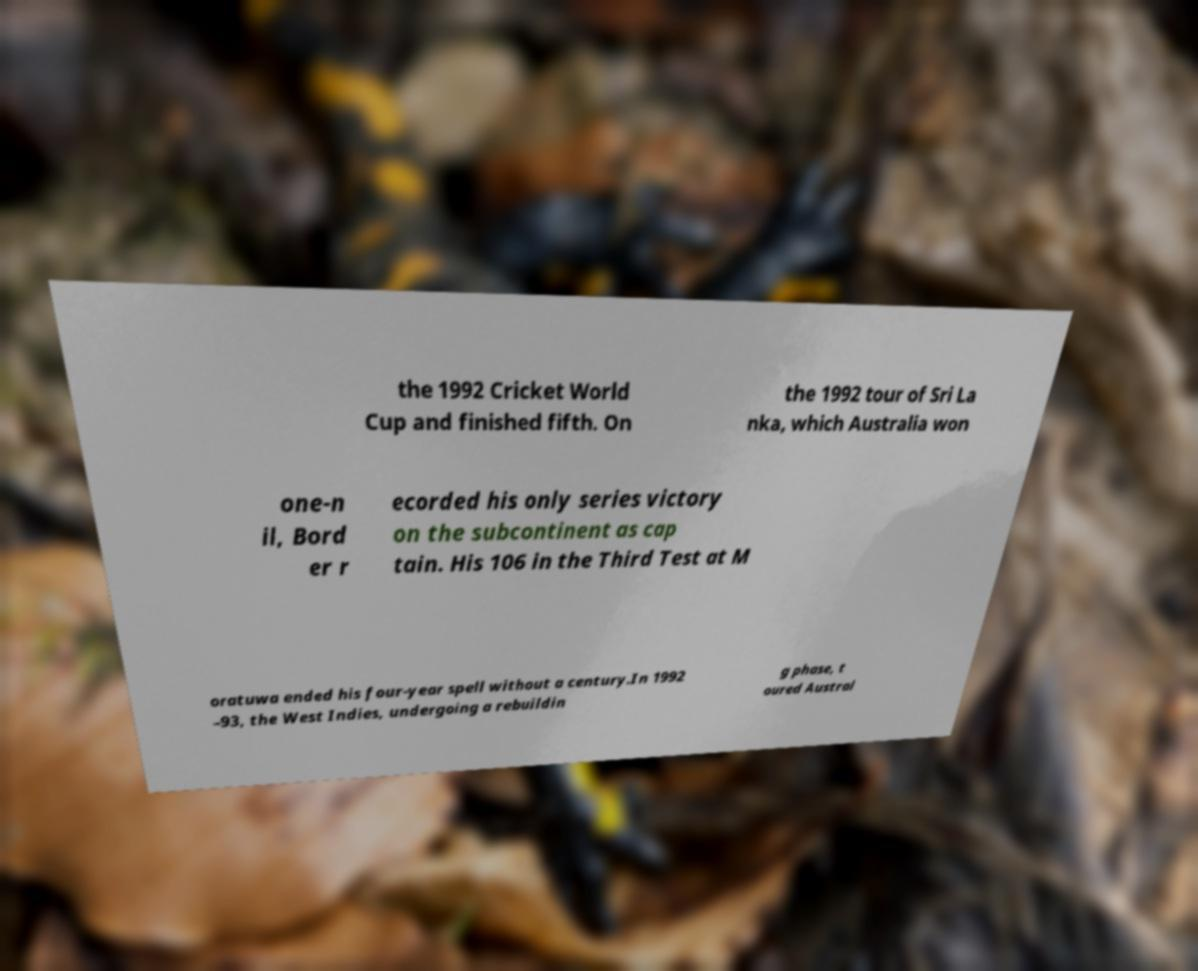Can you read and provide the text displayed in the image?This photo seems to have some interesting text. Can you extract and type it out for me? the 1992 Cricket World Cup and finished fifth. On the 1992 tour of Sri La nka, which Australia won one-n il, Bord er r ecorded his only series victory on the subcontinent as cap tain. His 106 in the Third Test at M oratuwa ended his four-year spell without a century.In 1992 –93, the West Indies, undergoing a rebuildin g phase, t oured Austral 